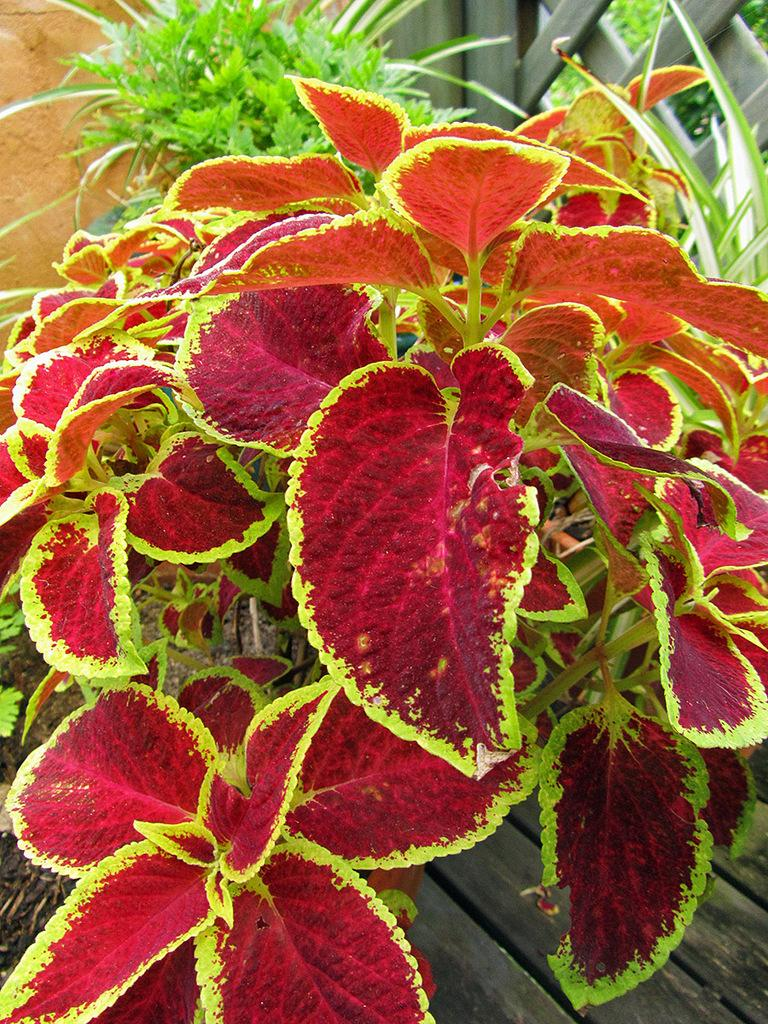What is placed on the wooden plank in the image? There are plants on a wooden plank in the image. Can you describe the appearance of the plants' leaves? The leaves of the plants are red in color with green borders. What else can be seen in the image besides the plants on the wooden plank? There are other plants visible in the background of the image. Reasoning: Let'g: Let's think step by step in order to produce the conversation. We start by identifying the main subject of the image, which is the plants on the wooden plank. Then, we describe the appearance of the plants' leaves, focusing on their unique color combination. Finally, we mention the presence of other plants in the background, providing a broader context for the image. Absurd Question/Answer: What type of donkey can be seen interacting with the plants on the wooden plank in the image? There is no donkey present in the image; it only features plants on a wooden plank and other plants in the background. What does the image smell like? The image does not have a smell, as it is a visual representation and not a physical object. 